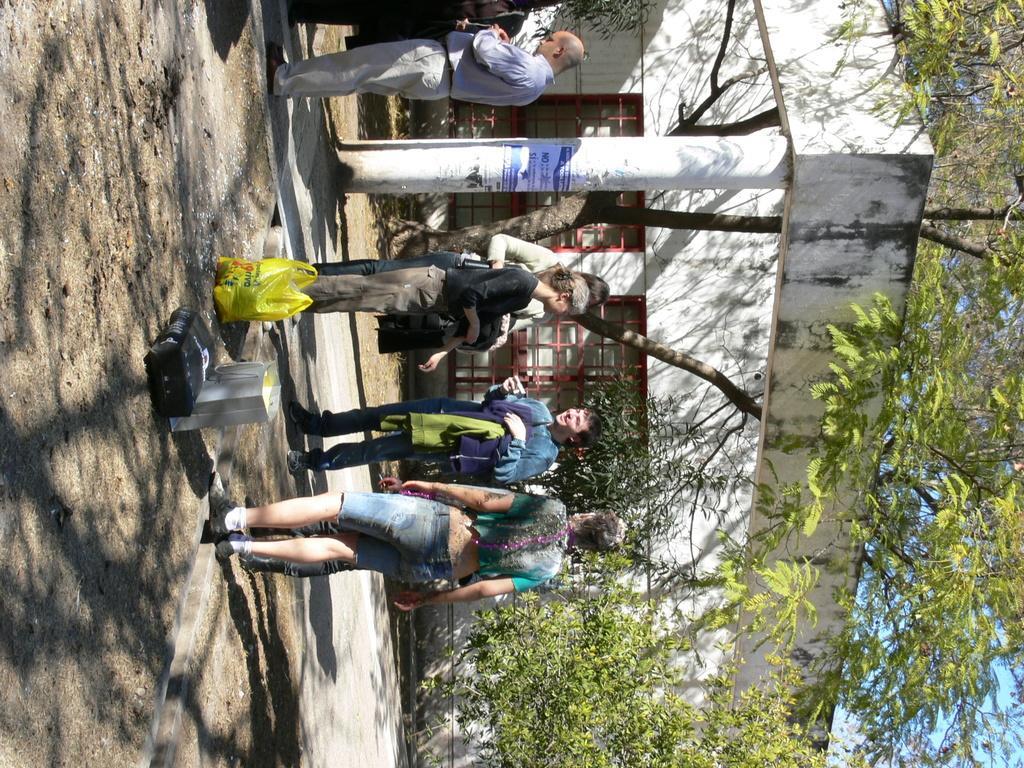Describe this image in one or two sentences. In this picture I can see few people are standing in front of the building and talking, side some objects are placed, around I can see some trees. 